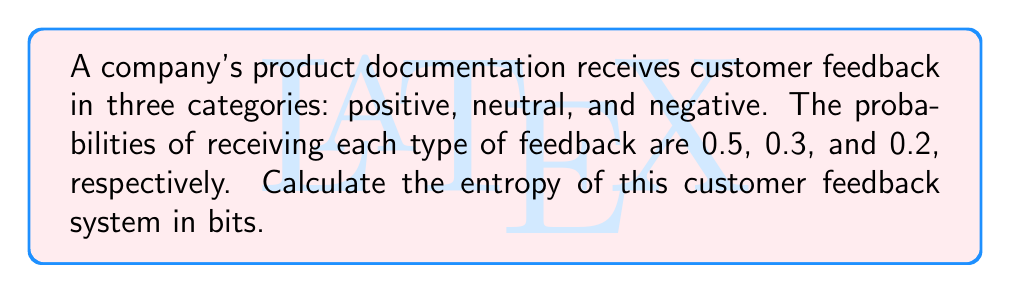Solve this math problem. To calculate the entropy of the customer feedback system, we'll use the Shannon entropy formula:

$$S = -\sum_{i=1}^{n} p_i \log_2(p_i)$$

Where:
$S$ is the entropy in bits
$p_i$ is the probability of each outcome
$n$ is the number of possible outcomes

Step 1: Identify the probabilities
$p_1 = 0.5$ (positive feedback)
$p_2 = 0.3$ (neutral feedback)
$p_3 = 0.2$ (negative feedback)

Step 2: Apply the entropy formula
$$\begin{align}
S &= -[p_1 \log_2(p_1) + p_2 \log_2(p_2) + p_3 \log_2(p_3)] \\
&= -[0.5 \log_2(0.5) + 0.3 \log_2(0.3) + 0.2 \log_2(0.2)]
\end{align}$$

Step 3: Calculate each term
$0.5 \log_2(0.5) \approx -0.5$
$0.3 \log_2(0.3) \approx -0.521$
$0.2 \log_2(0.2) \approx -0.464$

Step 4: Sum the terms and calculate the final result
$$S = -[-0.5 + (-0.521) + (-0.464)] \approx 1.485$$

Therefore, the entropy of the customer feedback system is approximately 1.485 bits.
Answer: 1.485 bits 